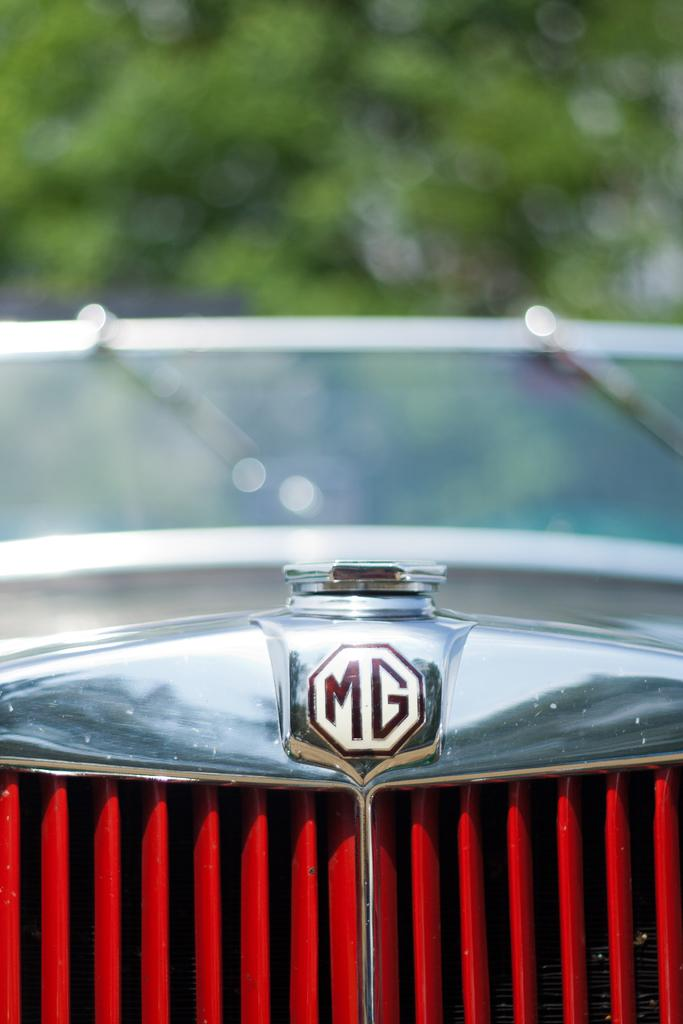What is the main subject of the image? The image shows a close view of a car radiator grill. What brand or model of car might the grill belong to? The "MG" monogram is visible on the grill, which suggests it belongs to an MG car. What can be seen in the background of the image? There is a green tree visible in the background. How is the background depicted in the image? The background is blurred. How much dirt can be seen on the channel in the image? There is no channel or dirt present in the image; it features a close view of a car radiator grill with a blurred background. --- Facts: 1. There is a person sitting on a bench in the image. 2. The person is reading a book. 3. The bench is located in a park. 4. There are trees in the background. 5. The sky is visible in the background. Absurd Topics: parrot, sand, volcano Conversation: What is the person in the image doing? The person is sitting on a bench in the image. What activity is the person engaged in while sitting on the bench? The person is reading a book. Where is the bench located? The bench is located in a park. What can be seen in the background of the image? There are trees and the sky visible in the background. Reasoning: Let's think step by step in order to produce the conversation. We start by identifying the main subject of the image, which is the person sitting on the bench. Then, we describe the person's activity, which is reading a book. Next, we provide information about the location of the bench, which is in a park. Finally, we mention the background elements, including trees and the sky. Absurd Question/Answer: Can you see any parrots or volcanoes in the image? No, there are no parrots or volcanoes present in the image. 